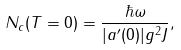Convert formula to latex. <formula><loc_0><loc_0><loc_500><loc_500>N _ { c } ( T = 0 ) = \frac { \hbar { \omega } } { | a ^ { \prime } ( 0 ) | g ^ { 2 } J } ,</formula> 